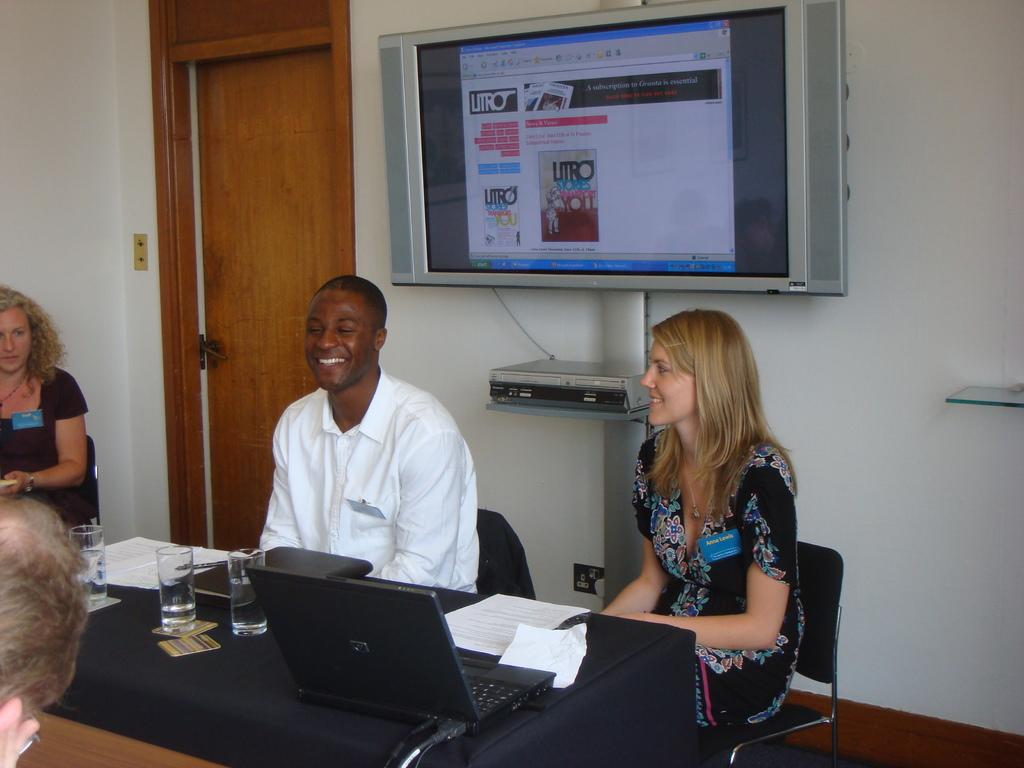What are the persons in the image doing? The persons in the image are sitting on chairs. Where are the chairs located in relation to the table? The chairs are near a table. What electronic device is on the table? There is a laptop on the table. What other objects are on the table? There is a glass and paper on the table. What is on the wall in the image? There is a television on the wall. What is beside the door in the image? There is a box beside the door. Is there a door visible in the image? Yes, there is a door in the image. What degree is the person holding in the image? There is no person holding a degree in the image. What type of lunch is being served on the table? There is no lunch present in the image. What is the mouth of the person doing in the image? There is no person or mouth visible in the image. 